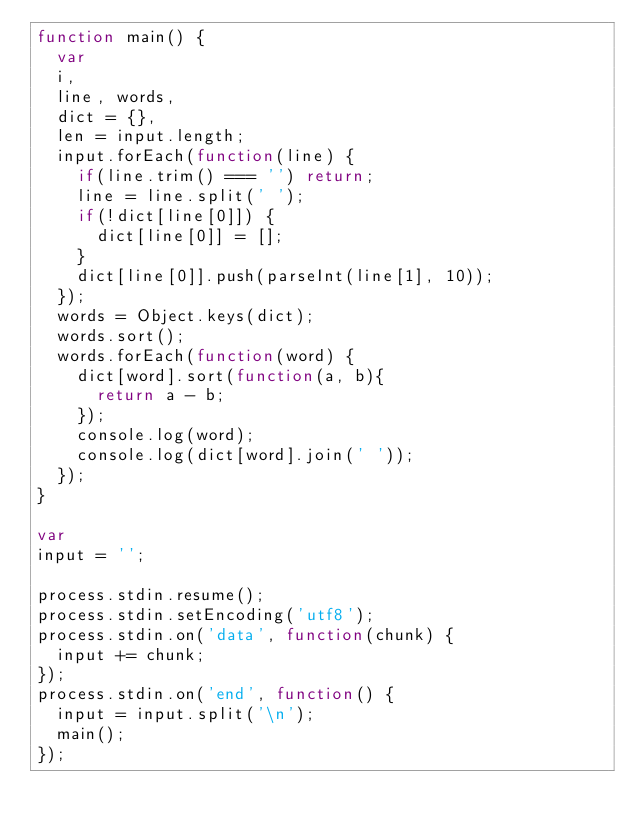<code> <loc_0><loc_0><loc_500><loc_500><_JavaScript_>function main() {
  var
  i,
  line, words,
  dict = {},
  len = input.length;
  input.forEach(function(line) {
    if(line.trim() === '') return;
    line = line.split(' ');
    if(!dict[line[0]]) {
      dict[line[0]] = [];
    }
    dict[line[0]].push(parseInt(line[1], 10));
  });
  words = Object.keys(dict);
  words.sort();
  words.forEach(function(word) {
    dict[word].sort(function(a, b){
      return a - b;
    });
    console.log(word);
    console.log(dict[word].join(' '));
  });
}

var
input = '';

process.stdin.resume();
process.stdin.setEncoding('utf8');
process.stdin.on('data', function(chunk) {
  input += chunk;
});
process.stdin.on('end', function() {
  input = input.split('\n');
  main();
});</code> 